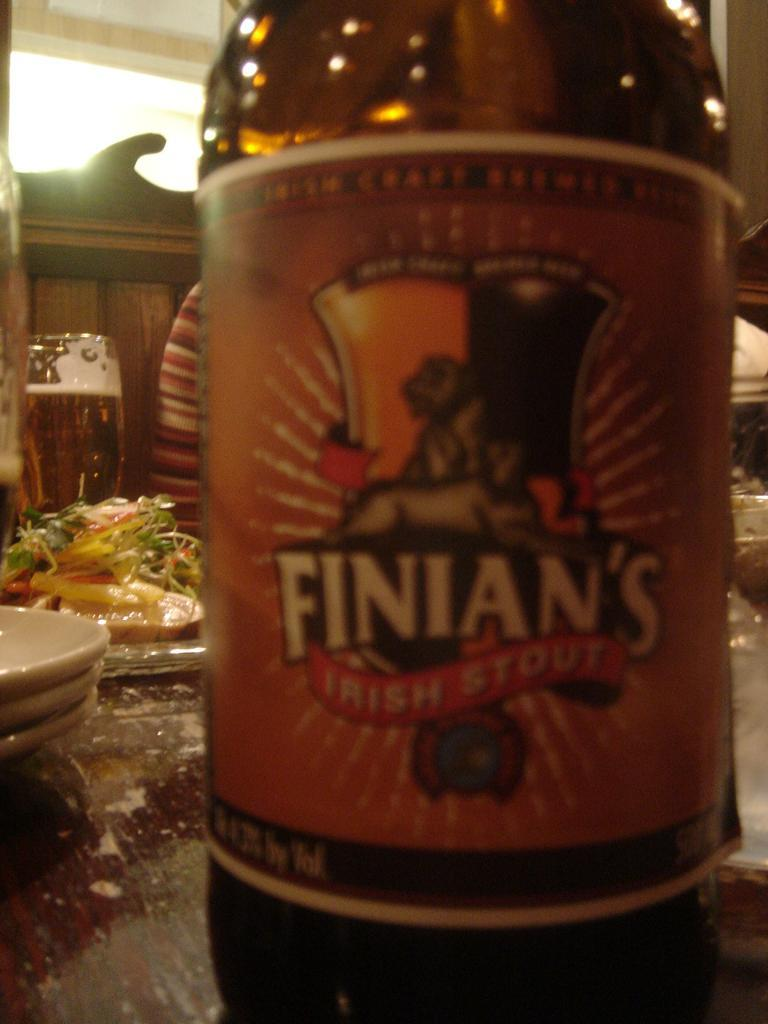Provide a one-sentence caption for the provided image. A Finian's Irish Stout beer bottle is on a restaurant table with lots of food on plates. 